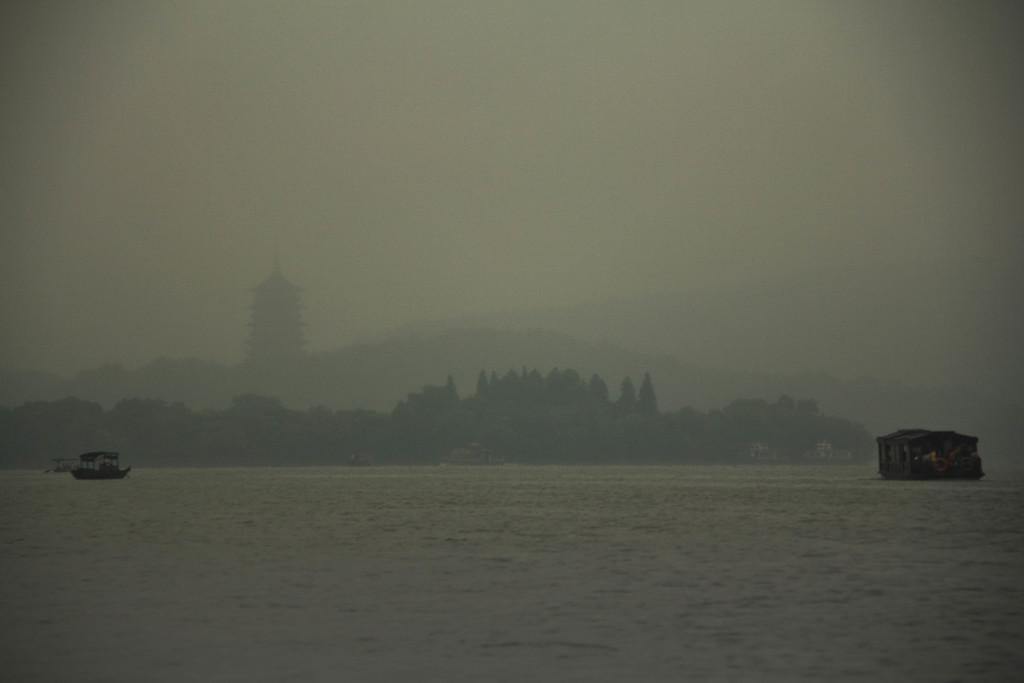Please provide a concise description of this image. In the picture I can see boats on the water. In the background I can see trees, a building and the sky. 